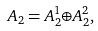<formula> <loc_0><loc_0><loc_500><loc_500>A _ { 2 } = A _ { 2 } ^ { 1 } { \oplus } A _ { 2 } ^ { 2 } ,</formula> 